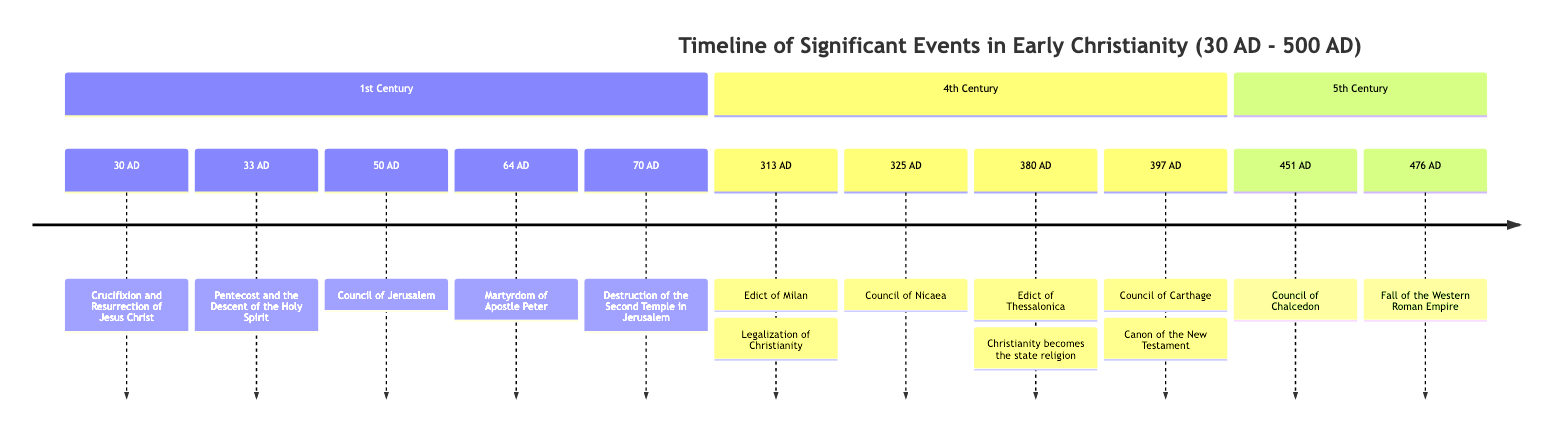What event occurred in 30 AD? The diagram lists "Crucifixion and Resurrection of Jesus Christ" as the event that took place in 30 AD.
Answer: Crucifixion and Resurrection of Jesus Christ How many significant events are listed in the 1st Century section? The 1st Century section includes five events: from the Crucifixion in 30 AD to the Destruction of the Second Temple in 70 AD. Counting these, we find five events.
Answer: 5 What year did the Edict of Milan occur? The diagram specifies that the Edict of Milan was issued in 313 AD.
Answer: 313 AD Which council established the canon of the New Testament? According to the timeline, the Council of Carthage in 397 AD established the canon of the New Testament.
Answer: Council of Carthage How many centuries are covered in the timeline? The timeline presents events from the 1st Century, 4th Century, and 5th Century, covering a total of three distinct centuries.
Answer: 3 What was the first event listed in the 4th Century? In the 4th Century section, the first event listed is the Edict of Milan, which occurred in 313 AD.
Answer: Edict of Milan What significant change occurred in 380 AD? The diagram notes that in 380 AD, the Edict of Thessalonica established Christianity as the state religion.
Answer: Christianity becomes the state religion How is the Martyrdom of Apostle Peter related to the timeline? The Martyrdom of Apostle Peter is placed in the 1st Century, specifically in 64 AD, as a key event that demonstrates the early persecution of Christians.
Answer: Martyrdom of Apostle Peter Which event marked the fall of the Western Roman Empire? The timeline indicates that the fall of the Western Roman Empire occurred in 476 AD.
Answer: Fall of the Western Roman Empire 